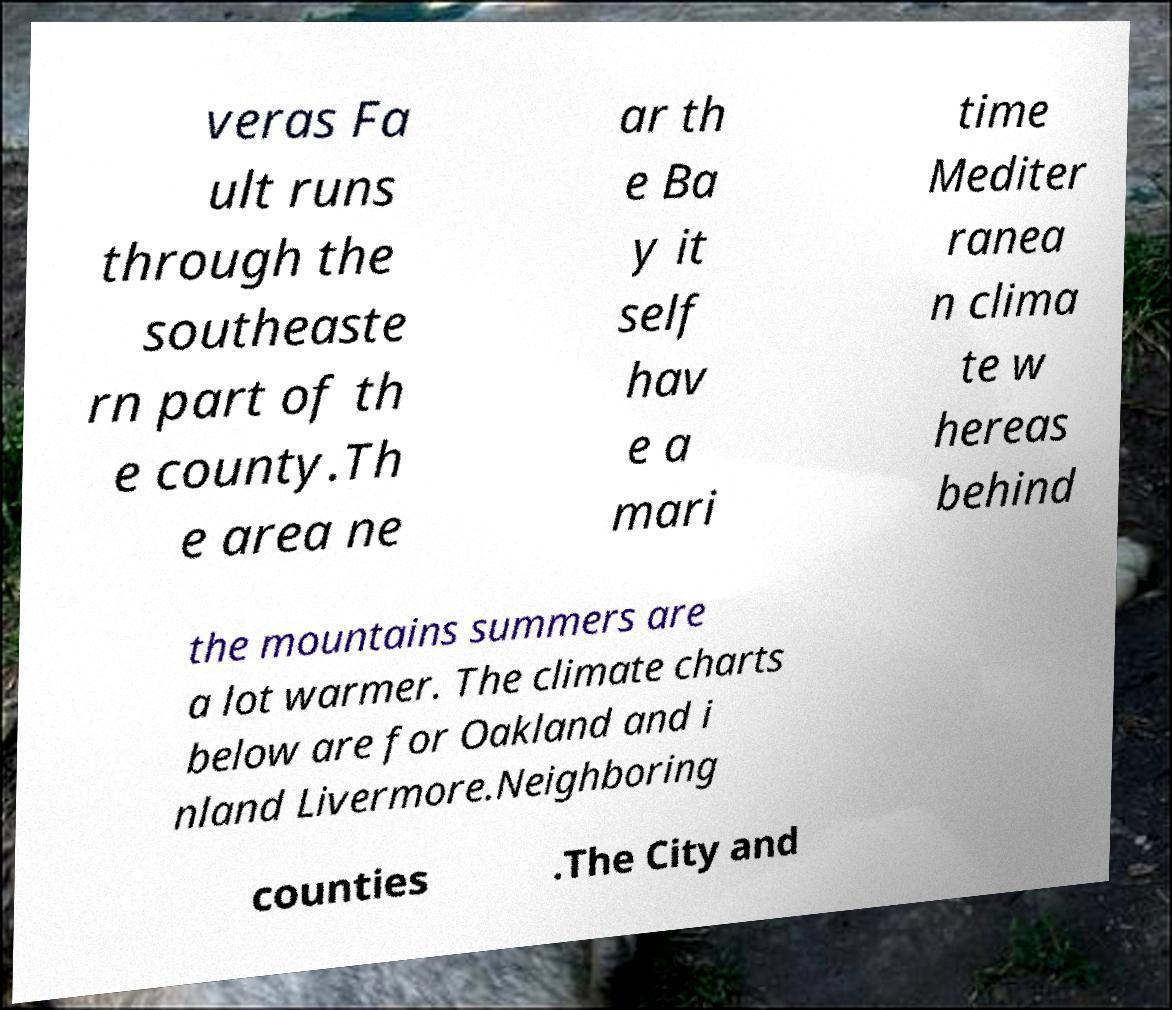What messages or text are displayed in this image? I need them in a readable, typed format. veras Fa ult runs through the southeaste rn part of th e county.Th e area ne ar th e Ba y it self hav e a mari time Mediter ranea n clima te w hereas behind the mountains summers are a lot warmer. The climate charts below are for Oakland and i nland Livermore.Neighboring counties .The City and 